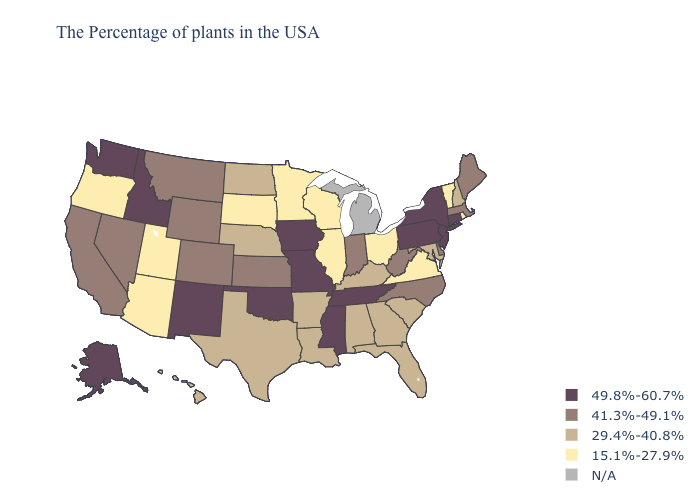What is the highest value in states that border Arizona?
Answer briefly. 49.8%-60.7%. Does the map have missing data?
Short answer required. Yes. What is the value of North Dakota?
Keep it brief. 29.4%-40.8%. Among the states that border North Dakota , does South Dakota have the lowest value?
Write a very short answer. Yes. Name the states that have a value in the range 29.4%-40.8%?
Concise answer only. New Hampshire, Maryland, South Carolina, Florida, Georgia, Kentucky, Alabama, Louisiana, Arkansas, Nebraska, Texas, North Dakota, Hawaii. Name the states that have a value in the range N/A?
Answer briefly. Michigan. Does Maine have the highest value in the USA?
Short answer required. No. Which states have the lowest value in the Northeast?
Concise answer only. Rhode Island, Vermont. Name the states that have a value in the range 29.4%-40.8%?
Answer briefly. New Hampshire, Maryland, South Carolina, Florida, Georgia, Kentucky, Alabama, Louisiana, Arkansas, Nebraska, Texas, North Dakota, Hawaii. Name the states that have a value in the range N/A?
Quick response, please. Michigan. Which states have the highest value in the USA?
Be succinct. Connecticut, New York, New Jersey, Pennsylvania, Tennessee, Mississippi, Missouri, Iowa, Oklahoma, New Mexico, Idaho, Washington, Alaska. Does Iowa have the lowest value in the MidWest?
Give a very brief answer. No. Does the map have missing data?
Keep it brief. Yes. What is the value of North Dakota?
Write a very short answer. 29.4%-40.8%. 